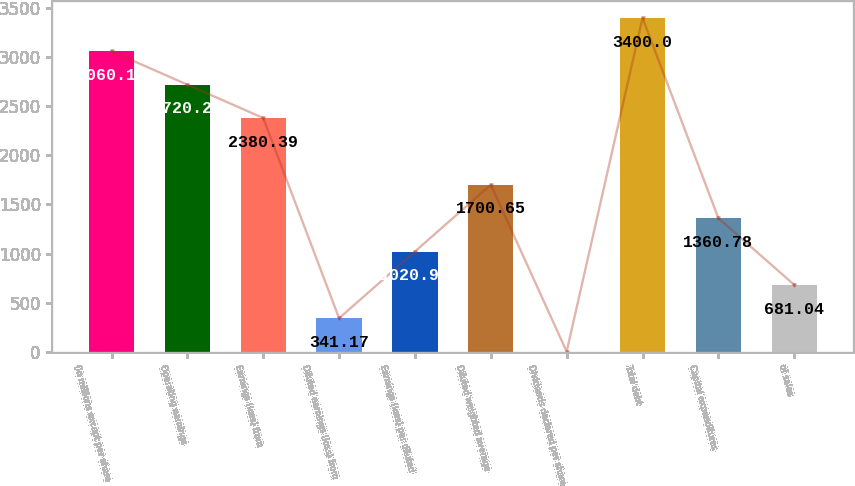Convert chart. <chart><loc_0><loc_0><loc_500><loc_500><bar_chart><fcel>(In millions except per share<fcel>Operating earnings<fcel>Earnings (loss) from<fcel>Diluted earnings (loss) from<fcel>Earnings (loss) per diluted<fcel>Diluted weighted average<fcel>Dividends declared per share<fcel>Total debt<fcel>Capital expenditures<fcel>of sales<nl><fcel>3060.13<fcel>2720.26<fcel>2380.39<fcel>341.17<fcel>1020.91<fcel>1700.65<fcel>1.3<fcel>3400<fcel>1360.78<fcel>681.04<nl></chart> 